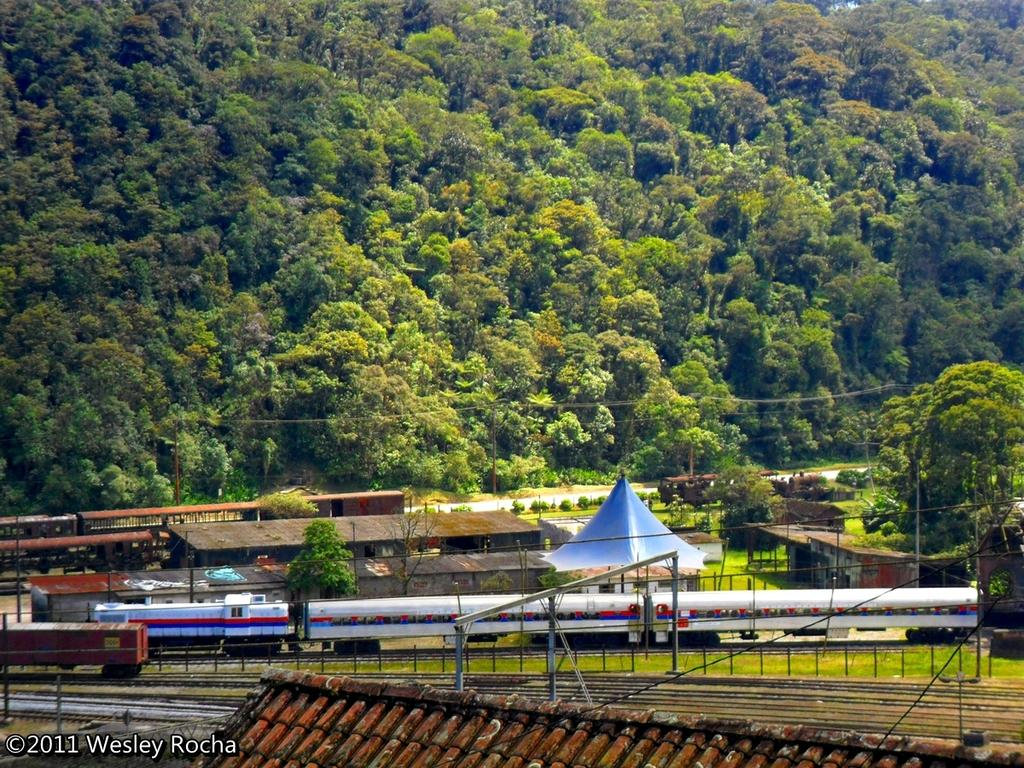What type of vehicles can be seen in the image? There are trains on railway tracks in the image. What type of vegetation is visible in the image? There is grass visible in the image. What type of barrier is present in the image? There is a fence in the image. What type of temporary shelter is present in the image? There is a tent in the image. What type of structures are visible in the image? There are houses in the image. What type of vertical structures are present in the image? There are poles in the image. What type of natural scenery is visible in the background of the image? There are trees in the background of the image. What type of trade is being conducted in the image? There is no indication of any trade being conducted in the image. What type of can is visible in the image? There is no can present in the image. 